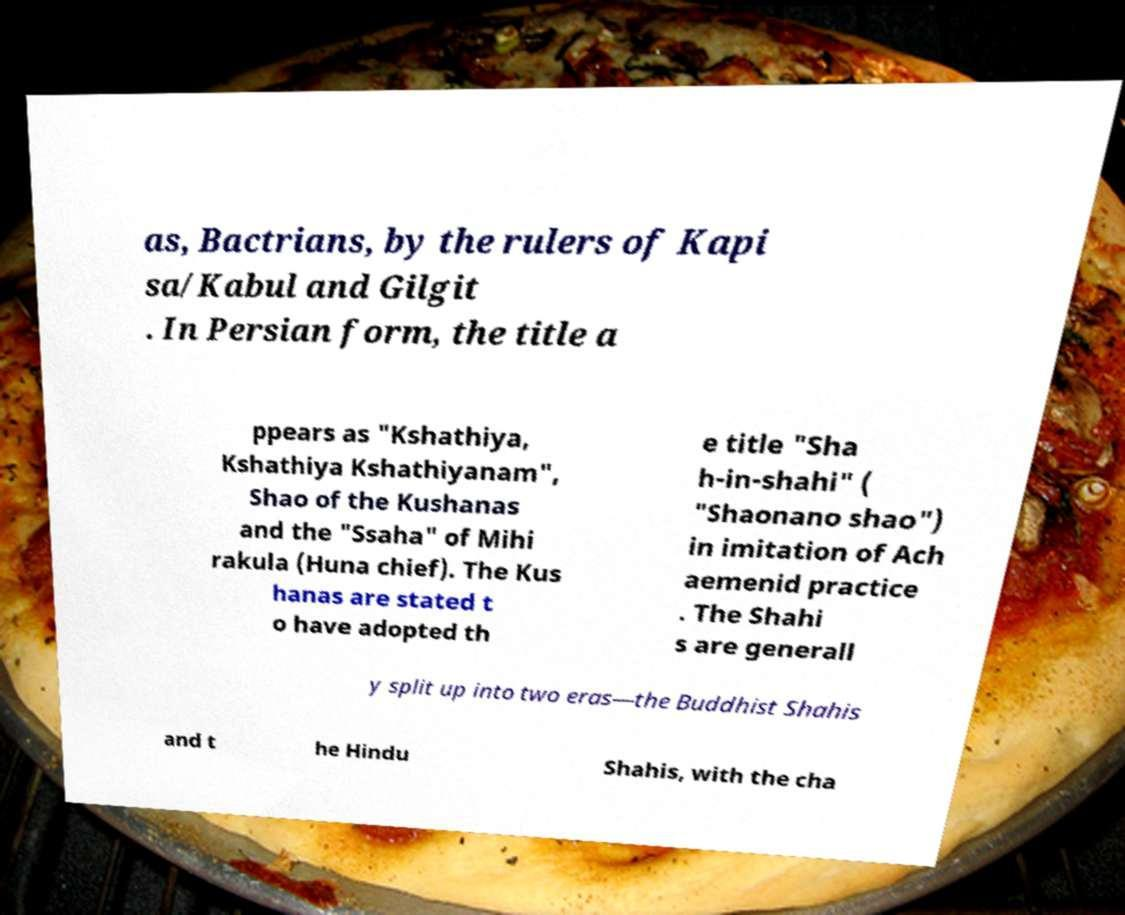What messages or text are displayed in this image? I need them in a readable, typed format. as, Bactrians, by the rulers of Kapi sa/Kabul and Gilgit . In Persian form, the title a ppears as "Kshathiya, Kshathiya Kshathiyanam", Shao of the Kushanas and the "Ssaha" of Mihi rakula (Huna chief). The Kus hanas are stated t o have adopted th e title "Sha h-in-shahi" ( "Shaonano shao") in imitation of Ach aemenid practice . The Shahi s are generall y split up into two eras—the Buddhist Shahis and t he Hindu Shahis, with the cha 